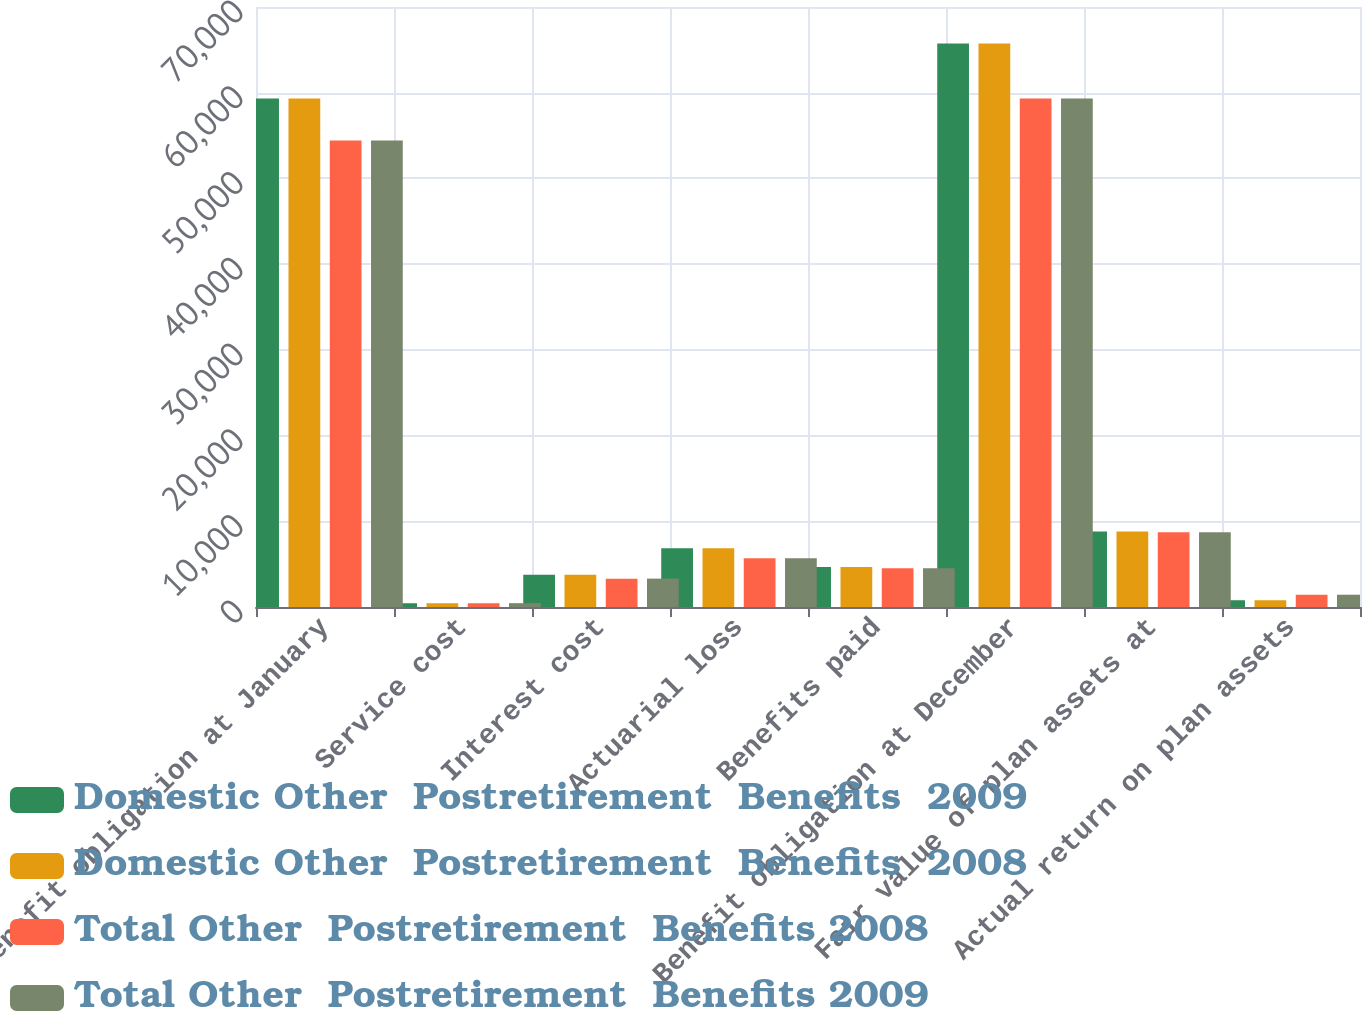Convert chart. <chart><loc_0><loc_0><loc_500><loc_500><stacked_bar_chart><ecel><fcel>Benefit obligation at January<fcel>Service cost<fcel>Interest cost<fcel>Actuarial loss<fcel>Benefits paid<fcel>Benefit obligation at December<fcel>Fair value of plan assets at<fcel>Actual return on plan assets<nl><fcel>Domestic Other  Postretirement  Benefits  2009<fcel>59325<fcel>438<fcel>3769<fcel>6862<fcel>4655<fcel>65739<fcel>8821<fcel>790<nl><fcel>Domestic Other  Postretirement  Benefits  2008<fcel>59325<fcel>438<fcel>3769<fcel>6862<fcel>4655<fcel>65739<fcel>8821<fcel>790<nl><fcel>Total Other  Postretirement  Benefits 2008<fcel>54413<fcel>446<fcel>3310<fcel>5682<fcel>4526<fcel>59325<fcel>8713<fcel>1434<nl><fcel>Total Other  Postretirement  Benefits 2009<fcel>54413<fcel>446<fcel>3310<fcel>5682<fcel>4526<fcel>59325<fcel>8713<fcel>1434<nl></chart> 